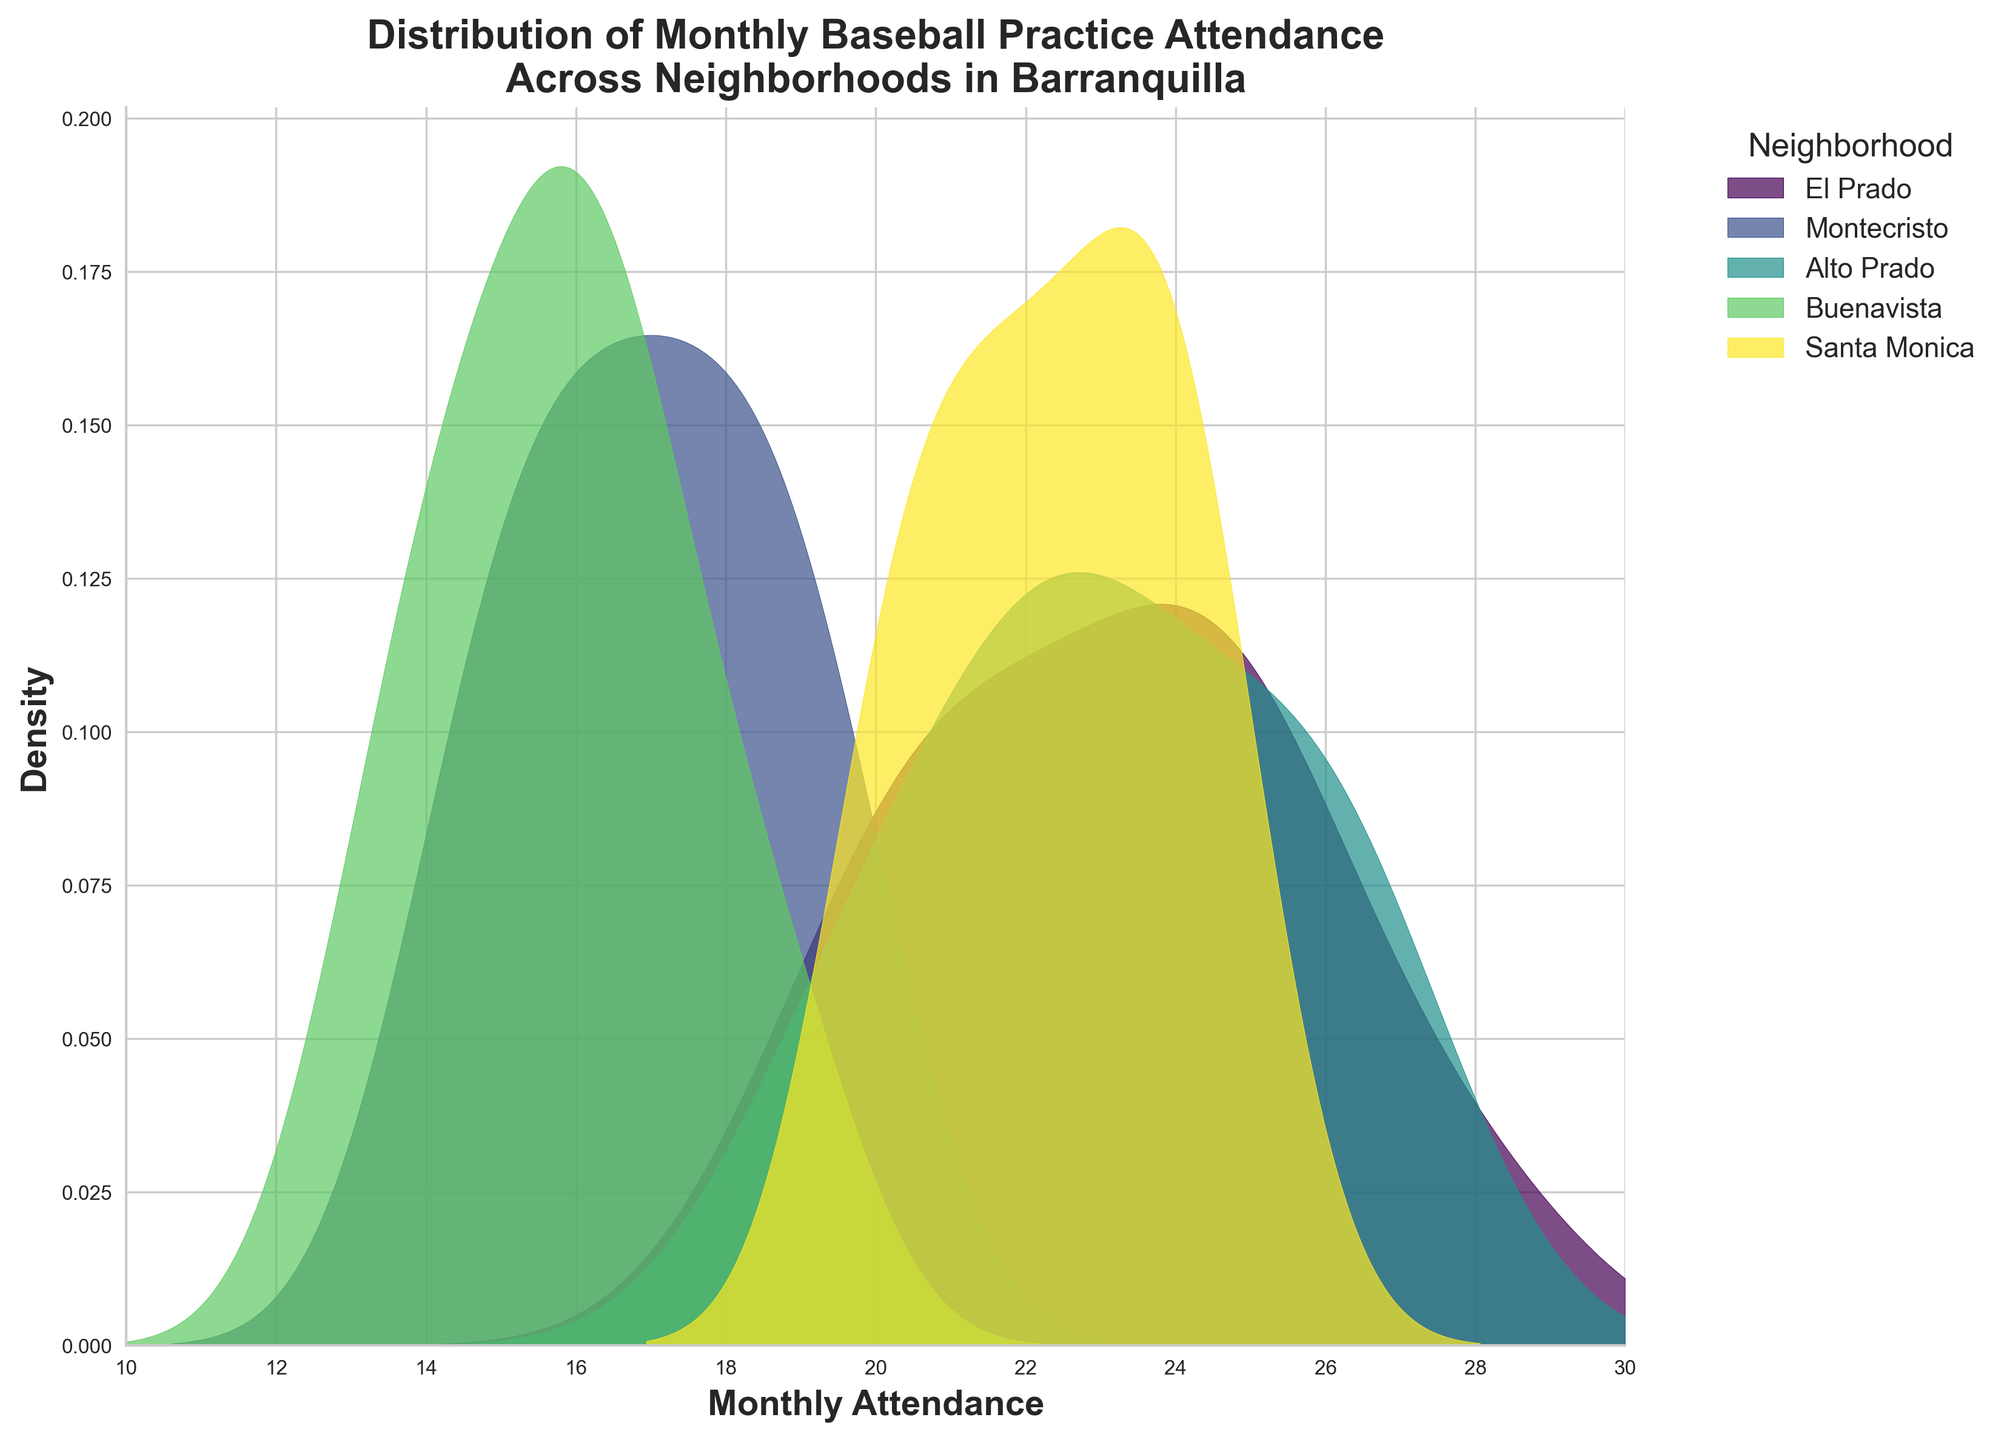How many neighborhoods are represented in the distribution plot? The legend indicates each neighborhood with a different color, and each entry in the legend represents a neighborhood. Counting these entries provides the number of neighborhoods.
Answer: 5 Which neighborhood has the sharpest peak in the distribution plot? By observing the density plot, the sharpest peak is the one with the highest value. Look for the neighborhood whose peak is the tallest.
Answer: Alto Prado What is the approximate attendance range for Buenavista? Finding the range involves identifying the minimum and maximum values on the x-axis where the distribution for Buenavista starts and ends.
Answer: 13 to 19 Which neighborhood shows a consistently higher attendance rate throughout the year? Look for the neighborhood with the density plot that is mostly concentrated towards the higher attendance values on the x-axis.
Answer: El Prado Compare the attendance distributions of El Prado and Montecristo. Which one has a more spread-out attendance? A more spread-out distribution has a wider density plot. Compare the widths of El Prado and Montecristo's density plots to determine this.
Answer: Montecristo Are there any neighborhoods with a bimodal distribution? If yes, which one(s)? To see if a neighborhood has a bimodal distribution, look for peaks; bimodal distributions have two distinct peaks.
Answer: No, there are no obvious bimodal distributions For which neighborhood is the attendance most commonly around 24? Identify the neighborhood whose density plot has a peak around the x-axis value of 24.
Answer: Santa Monica What is the highest attendance value represented in the Alto Prado distribution? The x-axis value where the Alto Prado distribution tails off to the right indicates the highest attendance value.
Answer: 27 Which neighborhood has the lowest maximum attendance value? Find the peak or end point of each neighborhood's density plot on the x-axis, and determine which one has the lowest value.
Answer: Buenavista Looking at the plot, which neighborhood displays the most uniform distribution? The most uniform distribution will have the flattest density plot without sharp peaks. Identify the densest flat line.
Answer: Santa Monica 